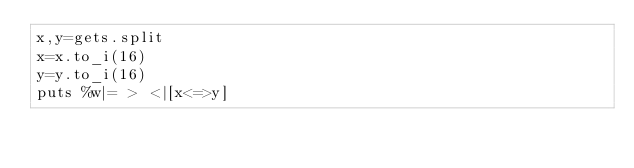<code> <loc_0><loc_0><loc_500><loc_500><_Ruby_>x,y=gets.split
x=x.to_i(16)
y=y.to_i(16)
puts %w|= > <|[x<=>y]
</code> 